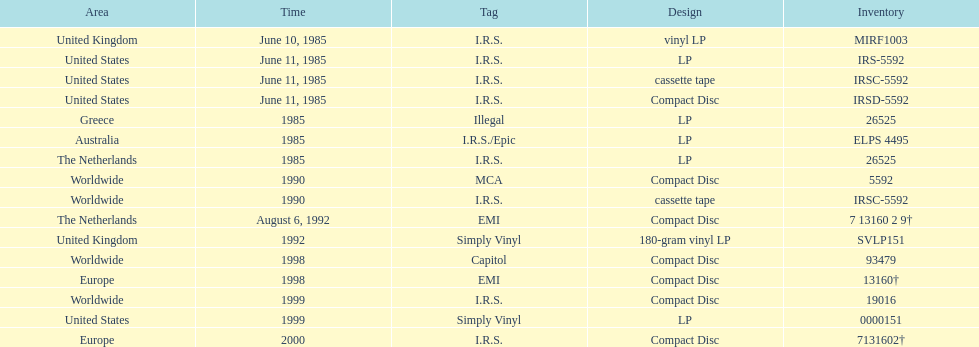What was the last region to experience the release? Europe. 